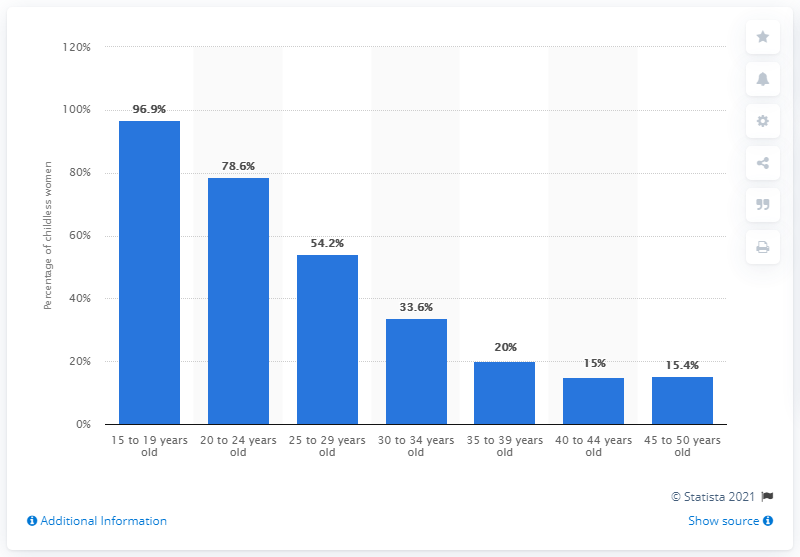List a handful of essential elements in this visual. The percentage difference between 15 to 19 year old individuals and 40 to 44 year old individuals is 81.9%. The lowest value of the bar is 15. 